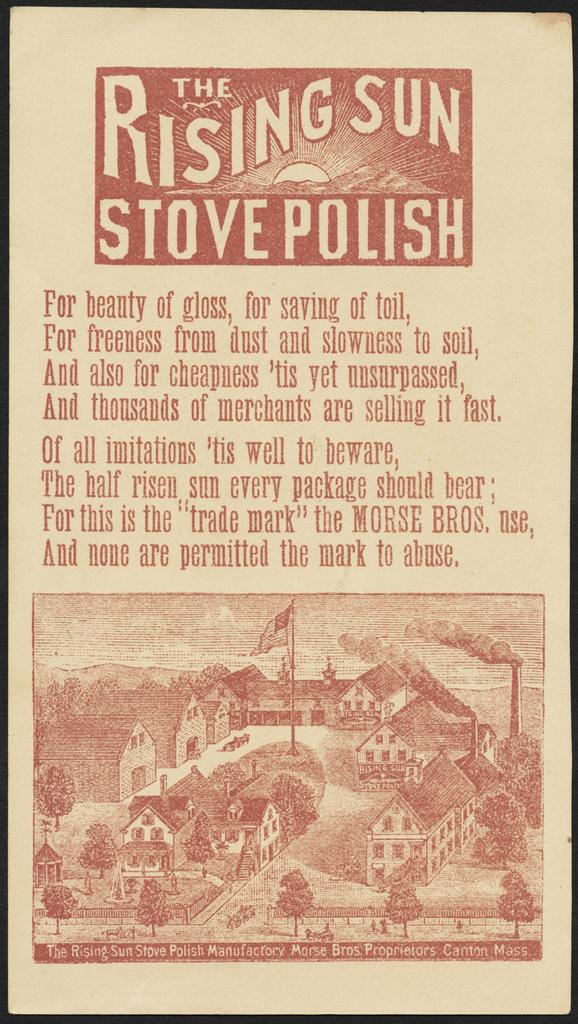Provide a one-sentence caption for the provided image. A label for the rising sun stove polish. 